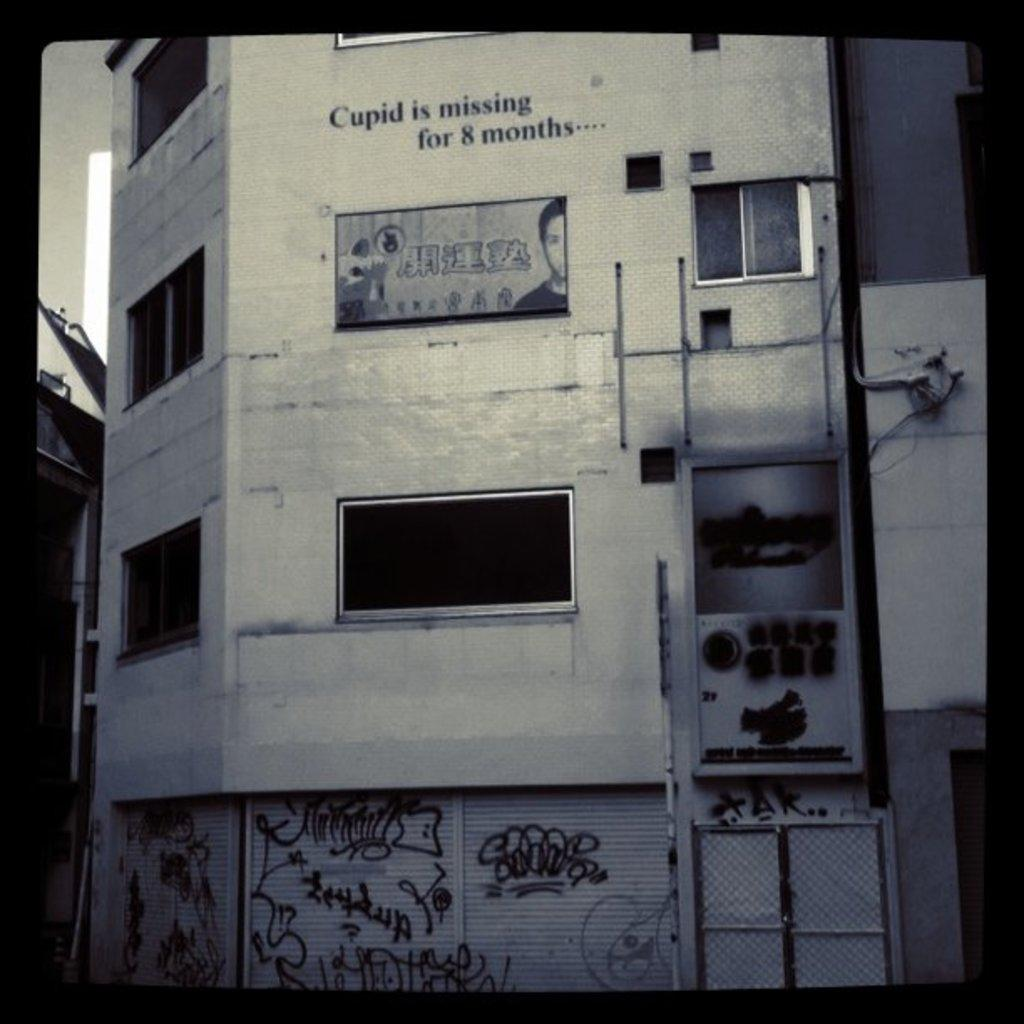What is the color scheme of the image? The image is black and white. What type of structure can be seen in the image? There is a building in the image. What object is present in the image that might be used for displaying information or advertisements? There is a board in the image. What architectural features are visible in the image? There are windows, shutters, a door, and a wall visible in the image. What type of markings or artwork can be seen on the building in the image? There is graffiti in the image. What is the background of the image? There is sky visible in the image. What type of text can be seen in the image? There is text in the image. How does the rain affect the building in the image? There is no rain present in the image, so its effect on the building cannot be determined. 